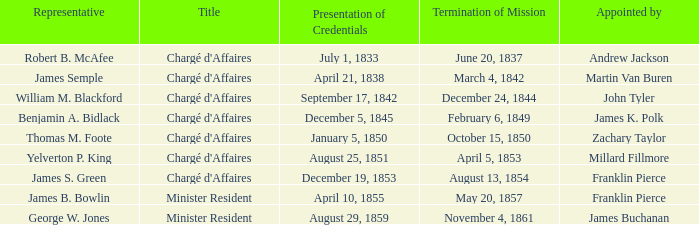What Title has a Termination of Mission for August 13, 1854? Chargé d'Affaires. 